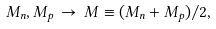Convert formula to latex. <formula><loc_0><loc_0><loc_500><loc_500>M _ { n } , M _ { p } \, \rightarrow \, M \equiv ( M _ { n } + M _ { p } ) / 2 ,</formula> 